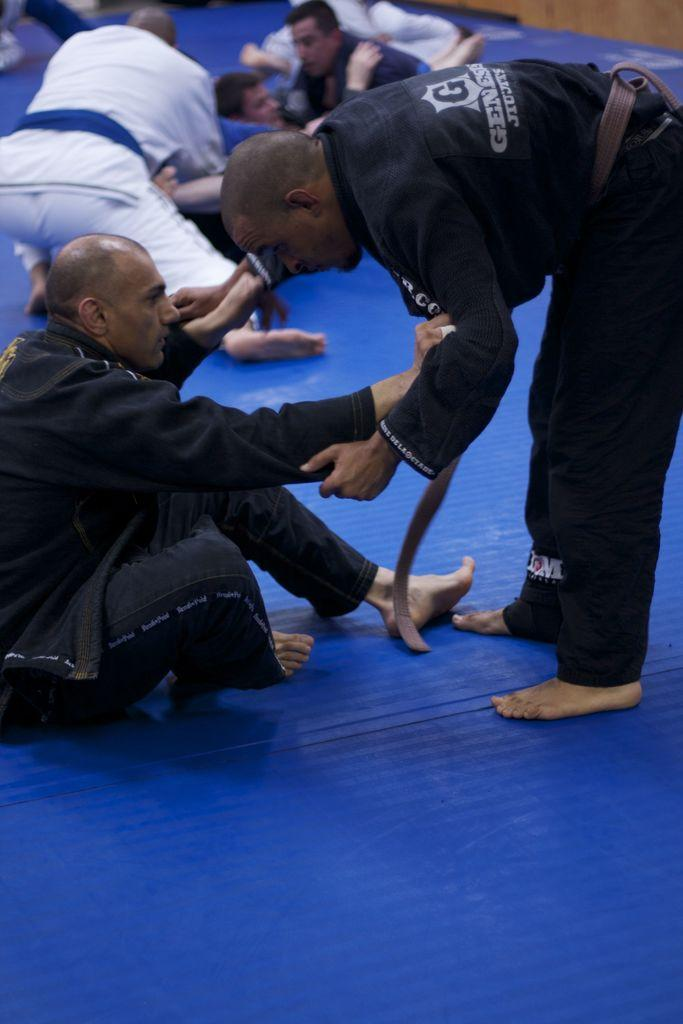What are the men in the image doing? The men in the image are sitting. Can you describe the man standing in the image? There is a man standing on a blue color mat in the image. How much bread is visible in the image? There is no bread present in the image. How many feet can be seen in the image? The number of feet visible in the image cannot be determined from the provided facts. 